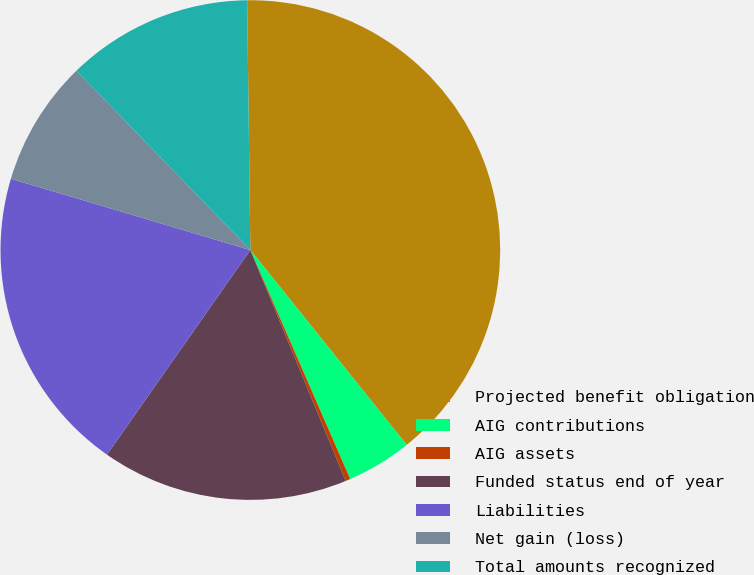Convert chart. <chart><loc_0><loc_0><loc_500><loc_500><pie_chart><fcel>Projected benefit obligation<fcel>AIG contributions<fcel>AIG assets<fcel>Funded status end of year<fcel>Liabilities<fcel>Net gain (loss)<fcel>Total amounts recognized<nl><fcel>39.44%<fcel>4.22%<fcel>0.31%<fcel>15.96%<fcel>19.88%<fcel>8.14%<fcel>12.05%<nl></chart> 